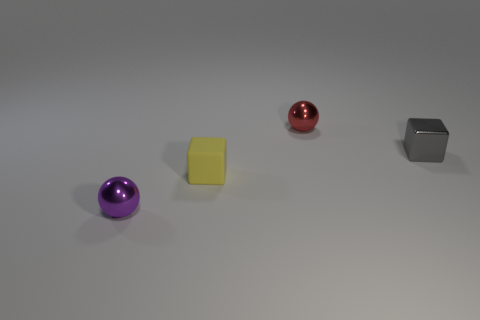Is there anything else that has the same material as the small yellow cube?
Make the answer very short. No. The object that is behind the small cube that is right of the tiny red metal thing is what shape?
Ensure brevity in your answer.  Sphere. The purple object that is made of the same material as the small red object is what shape?
Offer a terse response. Sphere. How many other objects are the same shape as the gray thing?
Offer a very short reply. 1. There is a metal sphere in front of the yellow object; is it the same size as the rubber thing?
Make the answer very short. Yes. Are there more metal things behind the purple ball than small red balls?
Make the answer very short. Yes. How many purple objects are behind the block behind the rubber object?
Offer a very short reply. 0. Are there fewer purple spheres that are to the right of the red metallic ball than tiny cubes?
Keep it short and to the point. Yes. There is a shiny thing on the left side of the ball behind the small purple metallic thing; is there a small shiny block behind it?
Your response must be concise. Yes. Is the material of the purple object the same as the small block on the left side of the tiny metallic block?
Offer a very short reply. No. 